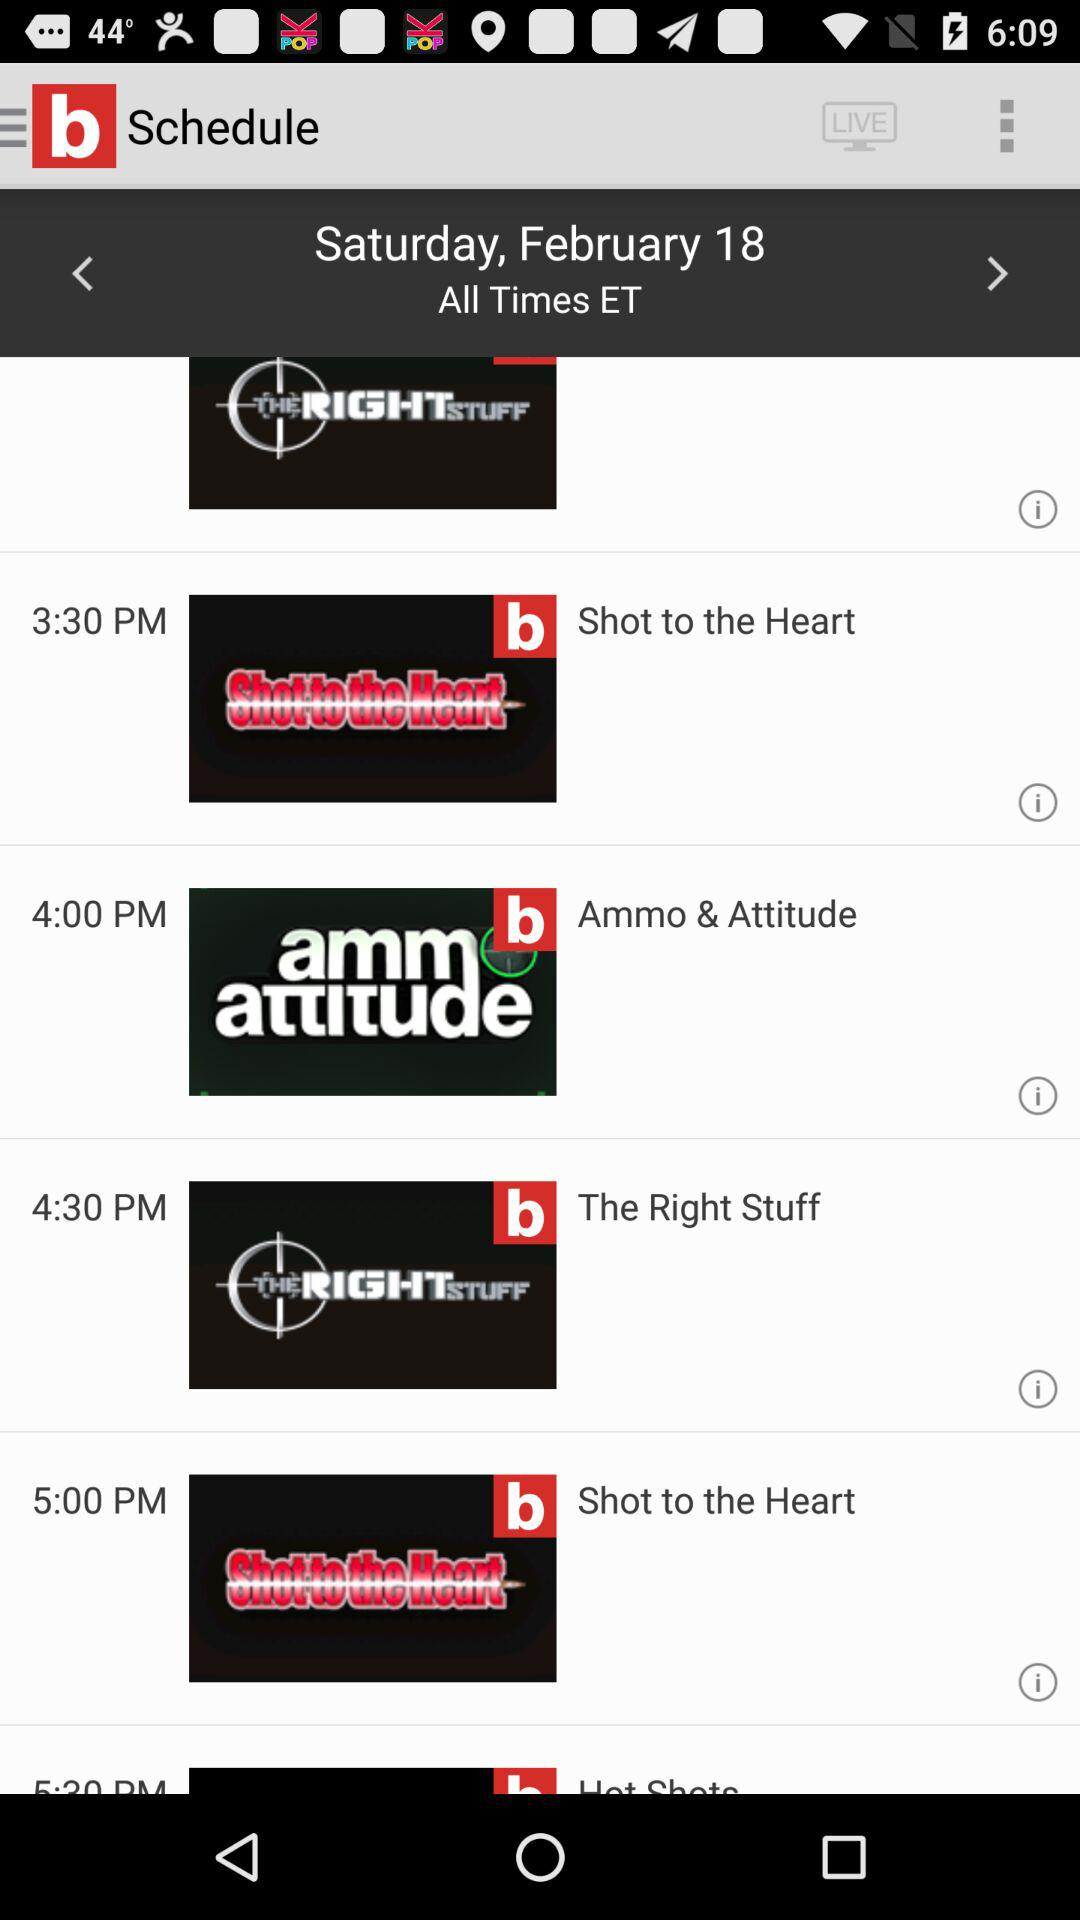What is the timing of "Ammo & Attitude"? The timing of "Ammo & Attitude" is 4:00 PM. 